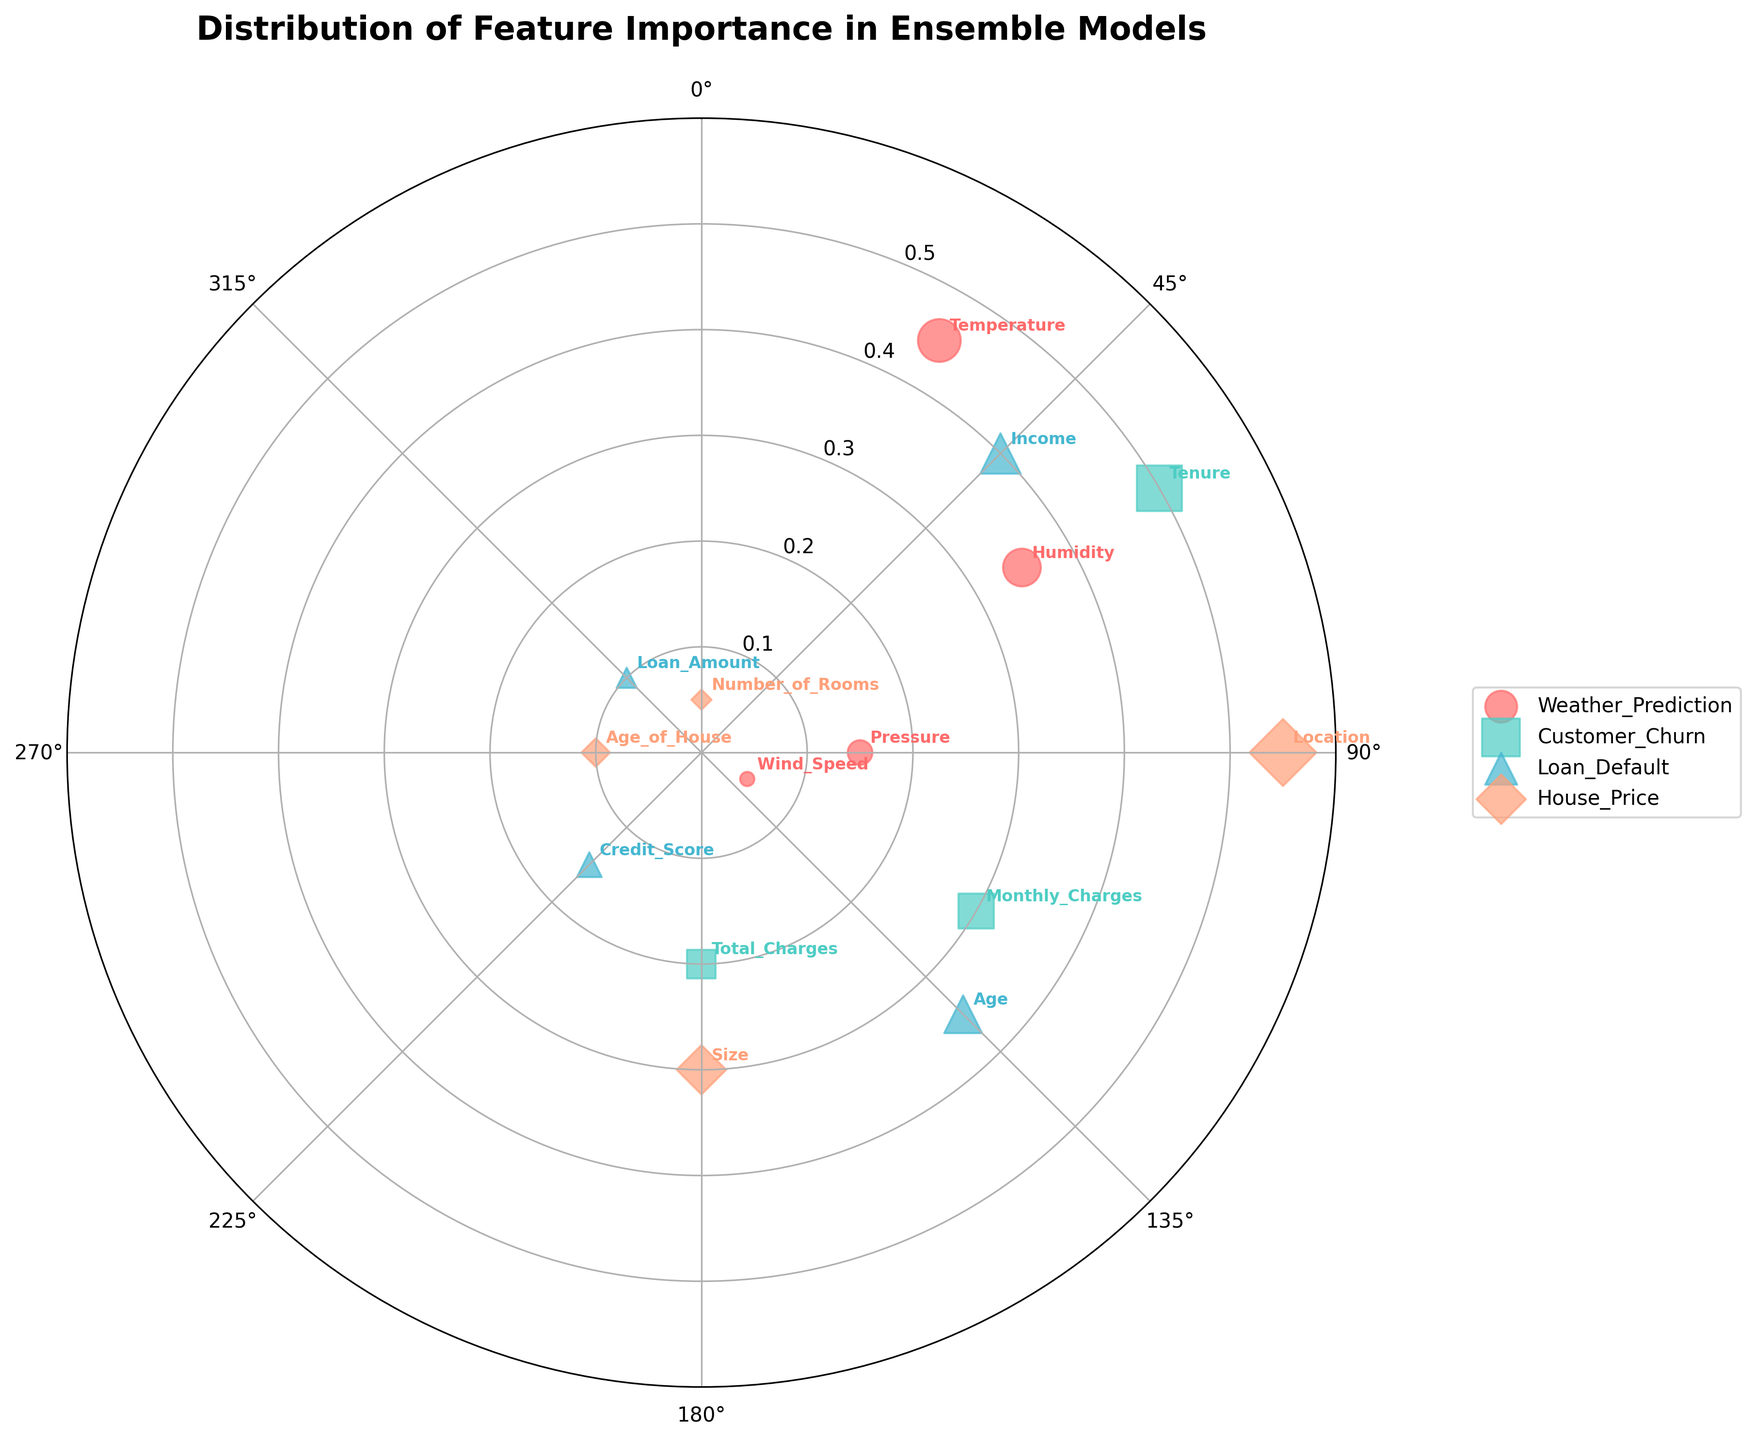What is the title of the chart? The title is displayed at the top center of the figure. It reads "Distribution of Feature Importance in Ensemble Models".
Answer: Distribution of Feature Importance in Ensemble Models Which dataset has the feature with the highest importance? The feature with the highest importance is at the top of the radial axis, thus, the feature of the "House_Price" dataset "Location" with an importance of 0.55 is the highest.
Answer: House_Price How many features are being analyzed for each dataset? The figure shows four unique markers, one for each dataset, with four features labeled around the plot for each respective dataset.
Answer: 4 What is the feature importance of "Humidity" in the Weather_Prediction dataset? Locate the "Humidity" label in the Weather_Prediction dataset (first dataset listed) at approximately 60 degrees. The radial distance, or feature importance, is given as 0.35.
Answer: 0.35 Between "Credit_Score" and "Loan_Amount" in the Loan_Default dataset, which feature has the lowest importance? Identify the Loan_Default dataset (marker typically noted in legend) and locate the "Credit_Score" at 225 degrees and "Loan_Amount" at 315 degrees. The radial distances show "Loan_Amount" at 0.10 as the lowest compared to "Credit_Score" at 0.15.
Answer: Loan_Amount Compare the importance of "Tenure" in the Customer_Churn dataset and "Age_of_House" in the House_Price dataset. Which has a higher value? Identify "Tenure" at 60 degrees in the Customer_Churn dataset and "Age_of_House" at 270 degrees in the House_Price dataset. Their radial distances indicate "Tenure" with 0.50 is higher than "Age_of_House" with 0.10.
Answer: Tenure What is the average importance of all features for the Weather_Prediction dataset? The Weather_Prediction dataset has the following importances: Temperature (0.45), Humidity (0.35), Pressure (0.15), and Wind_Speed (0.05). The average is calculated as (0.45 + 0.35 + 0.15 + 0.05) / 4 = 1.00 / 4 = 0.25.
Answer: 0.25 What are the angles (in degrees) associated with the Loan_Default dataset features? Using the markers and labels in the legend, the Loan_Default dataset's features are positioned at angles: Income (45), Age (135), Credit_Score (225), and Loan_Amount (315).
Answer: 45, 135, 225, 315 Which feature in the House_Price dataset is the closest to the center? By observing the feature radial distances within the House_Price dataset identified with their marker, the "Number_of_Rooms" at 360 degrees with an importance of 0.05 is the closest to the center.
Answer: Number_of_Rooms 